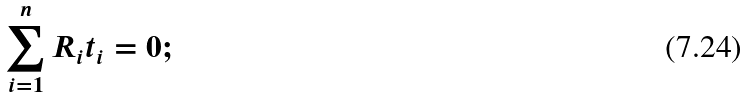<formula> <loc_0><loc_0><loc_500><loc_500>\sum _ { i = 1 } ^ { n } R _ { i } t _ { i } = 0 ;</formula> 